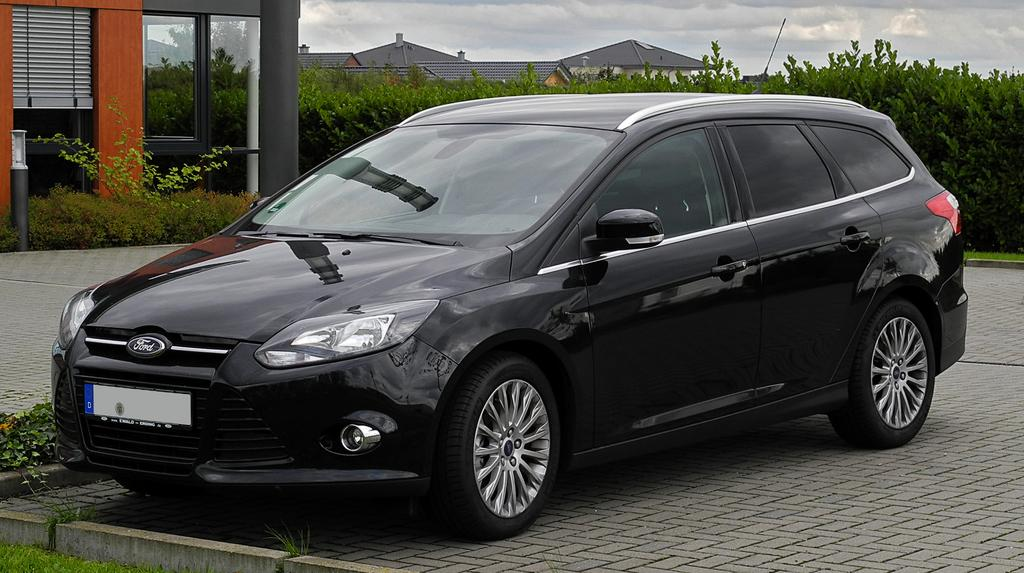What is on the road in the image? There is a car on the road in the image. What can be seen in the distance behind the car? There are buildings, glass doors, and trees in the background. What is visible in the sky in the image? There are clouds in the sky in the image. What type of club is being used to hit the car in the image? There is no club present in the image, and the car is not being hit by any object. 